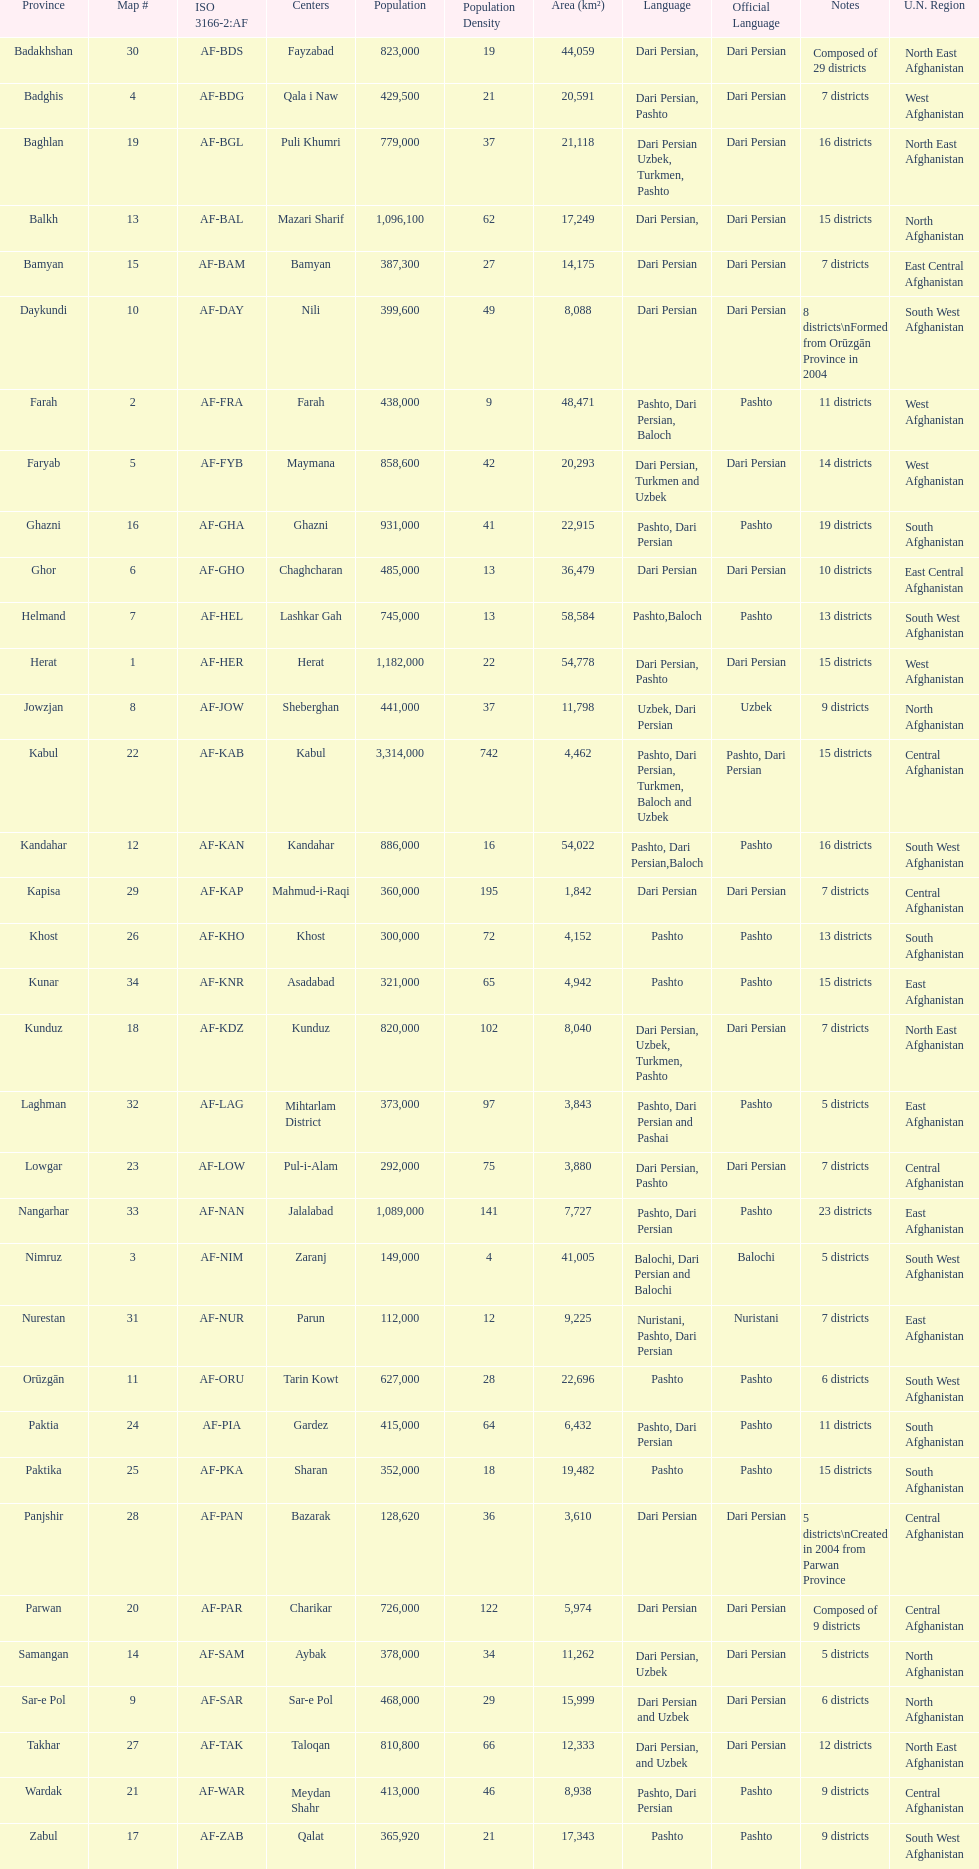What province is listed previous to ghor? Ghazni. 